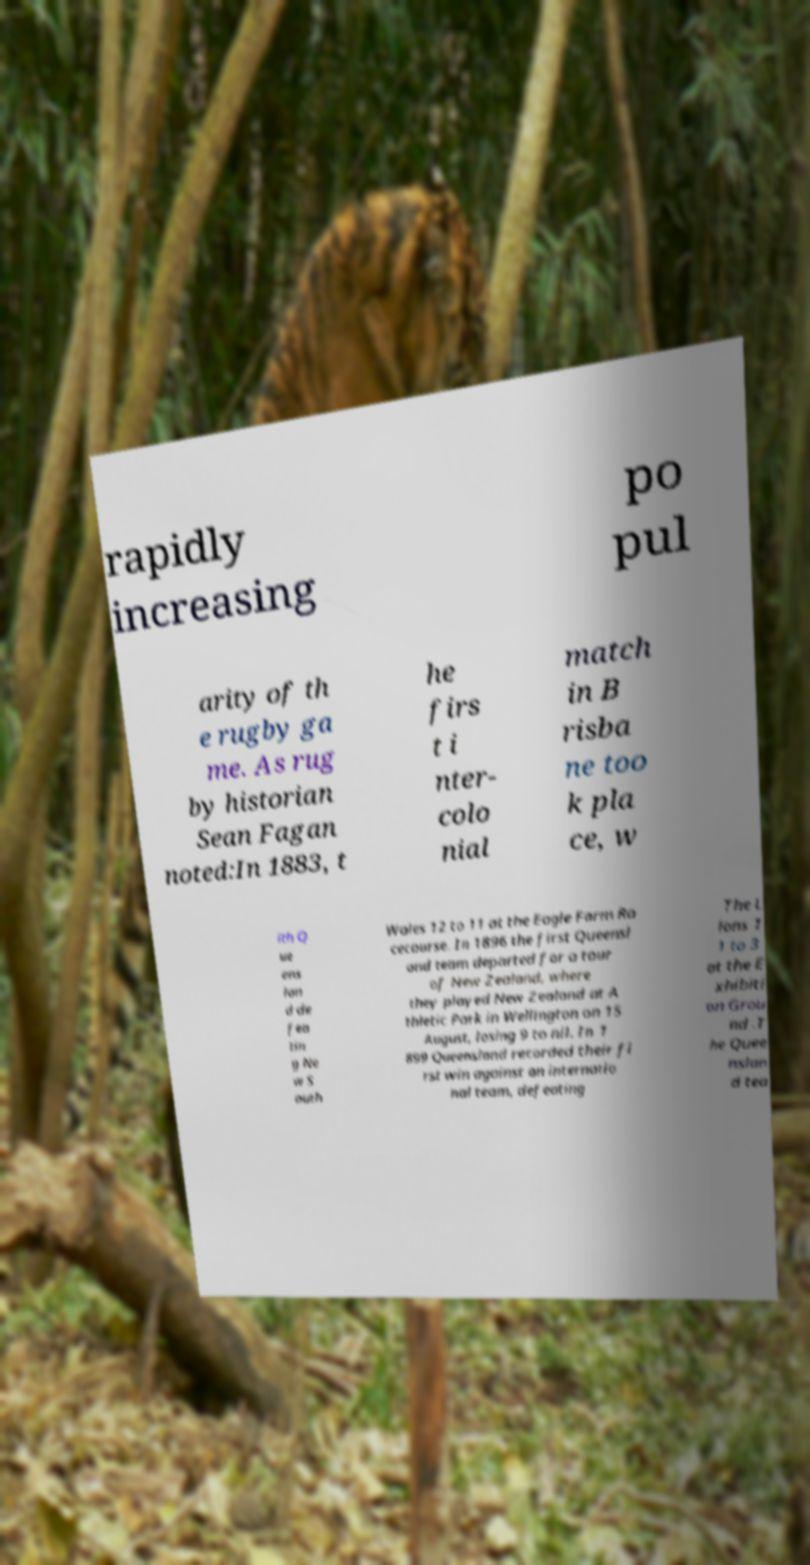For documentation purposes, I need the text within this image transcribed. Could you provide that? rapidly increasing po pul arity of th e rugby ga me. As rug by historian Sean Fagan noted:In 1883, t he firs t i nter- colo nial match in B risba ne too k pla ce, w ith Q ue ens lan d de fea tin g Ne w S outh Wales 12 to 11 at the Eagle Farm Ra cecourse. In 1896 the first Queensl and team departed for a tour of New Zealand, where they played New Zealand at A thletic Park in Wellington on 15 August, losing 9 to nil. In 1 899 Queensland recorded their fi rst win against an internatio nal team, defeating The L ions 1 1 to 3 at the E xhibiti on Grou nd .T he Quee nslan d tea 